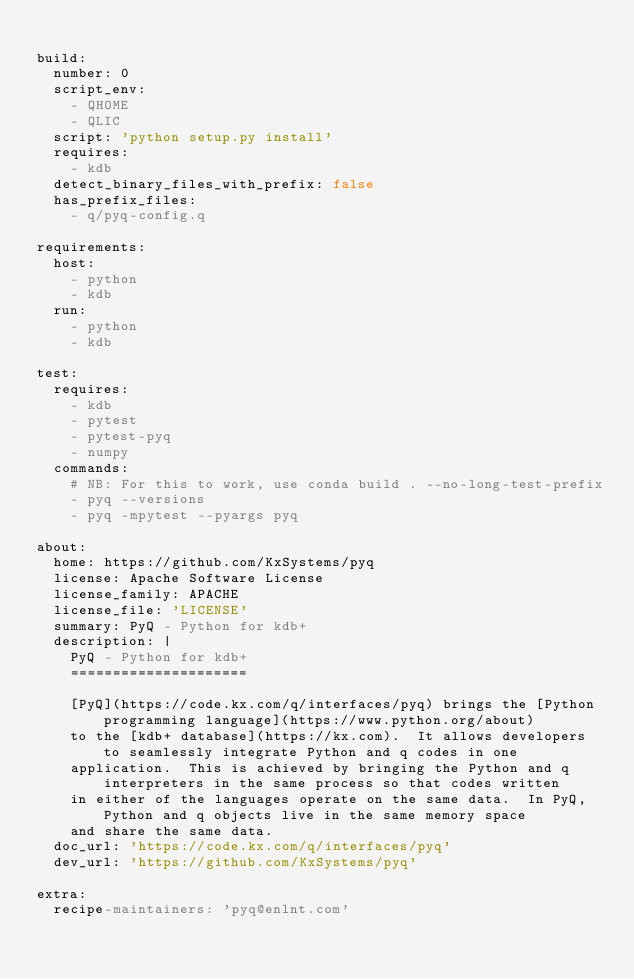<code> <loc_0><loc_0><loc_500><loc_500><_YAML_>
build:
  number: 0
  script_env:
    - QHOME
    - QLIC
  script: 'python setup.py install'
  requires:
    - kdb
  detect_binary_files_with_prefix: false
  has_prefix_files:
    - q/pyq-config.q

requirements:
  host:
    - python
    - kdb
  run:
    - python
    - kdb

test:
  requires:
    - kdb
    - pytest
    - pytest-pyq
    - numpy
  commands:
    # NB: For this to work, use conda build . --no-long-test-prefix
    - pyq --versions
    - pyq -mpytest --pyargs pyq

about:
  home: https://github.com/KxSystems/pyq
  license: Apache Software License
  license_family: APACHE
  license_file: 'LICENSE'
  summary: PyQ - Python for kdb+
  description: |
    PyQ - Python for kdb+
    =====================

    [PyQ](https://code.kx.com/q/interfaces/pyq) brings the [Python programming language](https://www.python.org/about)
    to the [kdb+ database](https://kx.com).  It allows developers to seamlessly integrate Python and q codes in one
    application.  This is achieved by bringing the Python and q interpreters in the same process so that codes written
    in either of the languages operate on the same data.  In PyQ, Python and q objects live in the same memory space
    and share the same data.
  doc_url: 'https://code.kx.com/q/interfaces/pyq'
  dev_url: 'https://github.com/KxSystems/pyq'

extra:
  recipe-maintainers: 'pyq@enlnt.com'
</code> 